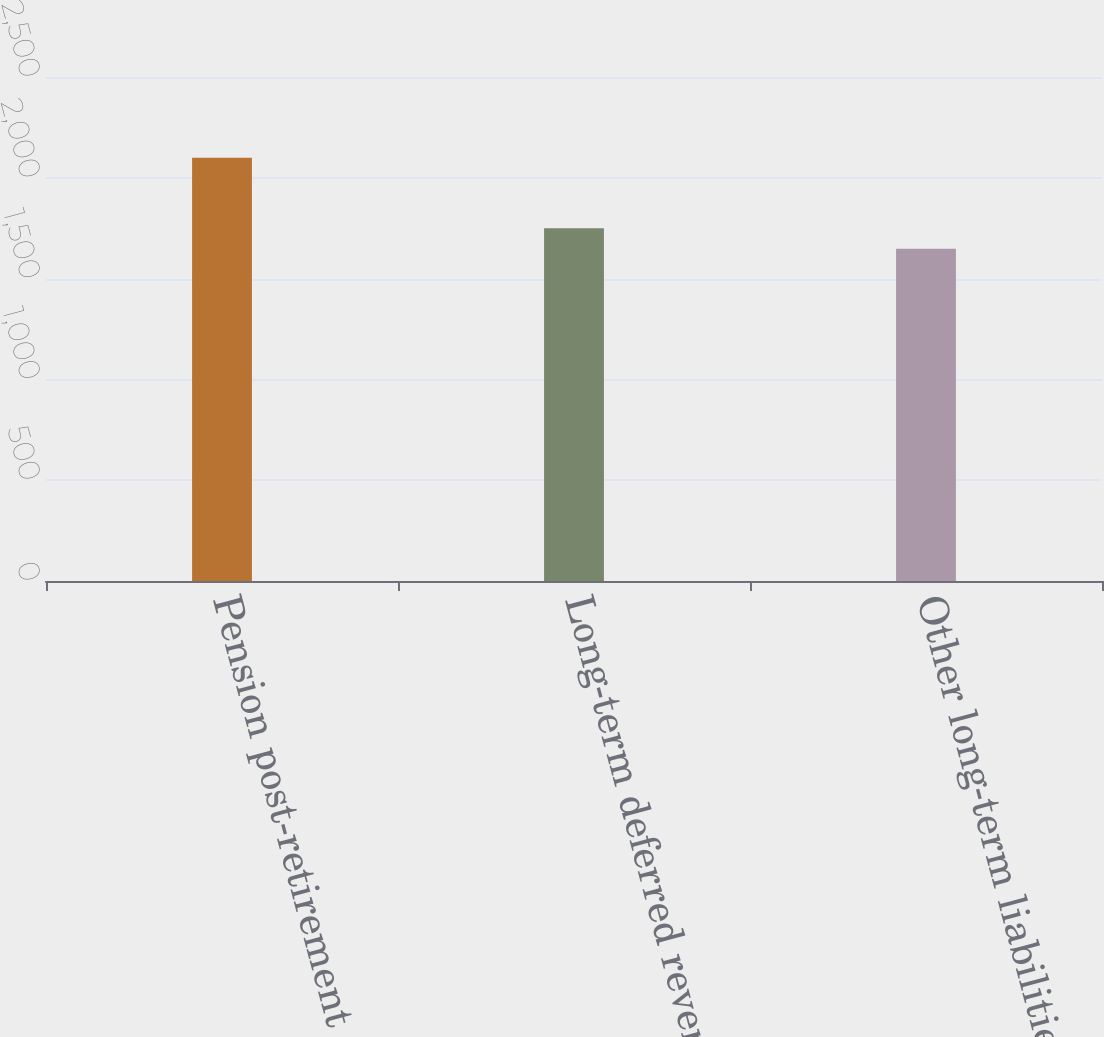Convert chart. <chart><loc_0><loc_0><loc_500><loc_500><bar_chart><fcel>Pension post-retirement and<fcel>Long-term deferred revenue<fcel>Other long-term liabilities<nl><fcel>2099<fcel>1750<fcel>1648<nl></chart> 